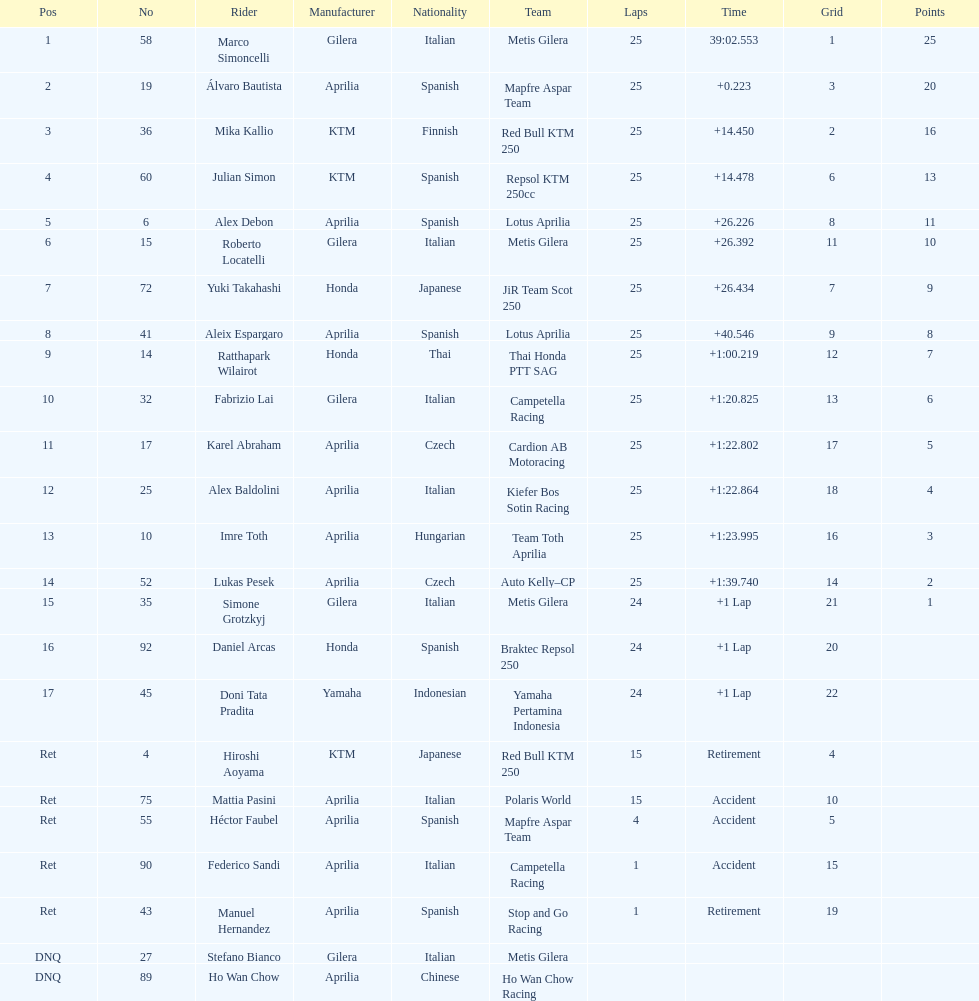What is the total number of laps performed by rider imre toth? 25. 